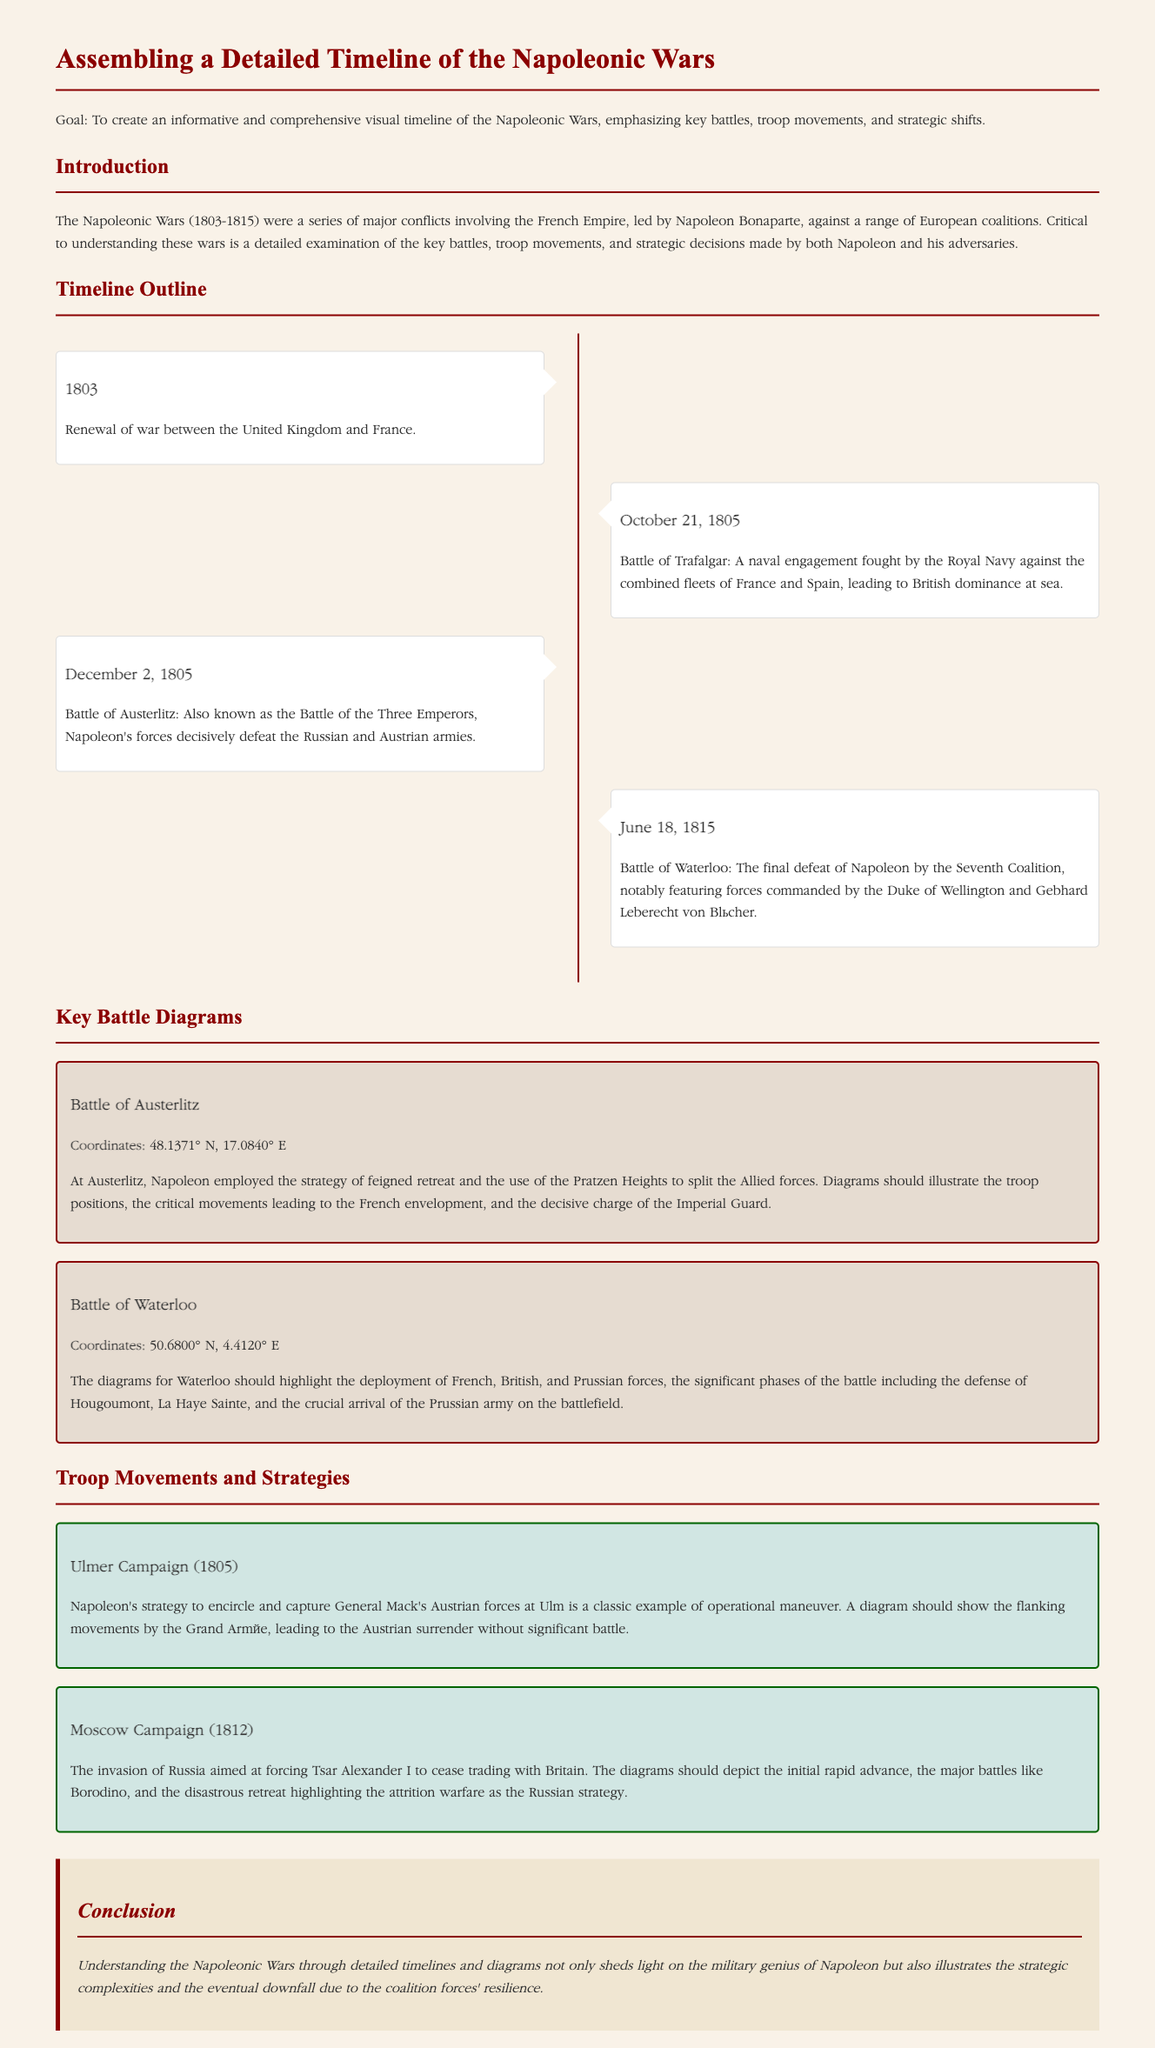What year did the Napoleonic Wars begin? The document states that the Napoleonic Wars began in 1803.
Answer: 1803 What was the date of the Battle of Trafalgar? The document notes that the Battle of Trafalgar occurred on October 21, 1805.
Answer: October 21, 1805 Which battle is known as the Battle of the Three Emperors? The document mentions that the Battle of Austerlitz is also known as the Battle of the Three Emperors.
Answer: Battle of Austerlitz What strategic advantage did Napoleon use at the Battle of Austerlitz? The document describes that Napoleon employed the strategy of feigned retreat at Austerlitz.
Answer: Feigned retreat How did Napoleon's forces fare at the Battle of Waterloo? The document states that the Battle of Waterloo was the final defeat of Napoleon.
Answer: Final defeat What was the main objective of Napoleon's Moscow Campaign? The document indicates that the invasion of Russia aimed to force Tsar Alexander I to cease trading with Britain.
Answer: Cease trading with Britain Which coalition defeated Napoleon at the Battle of Waterloo? The document refers to the Seventh Coalition defeating Napoleon at Waterloo.
Answer: Seventh Coalition What was a critical consequence of the Ulmer Campaign? The document notes that the Ulmer Campaign led to the Austrian surrender without significant battle.
Answer: Austrian surrender What color is used for the background of the timeline? The document specifies the background color of the timeline as #f9f2e8.
Answer: #f9f2e8 